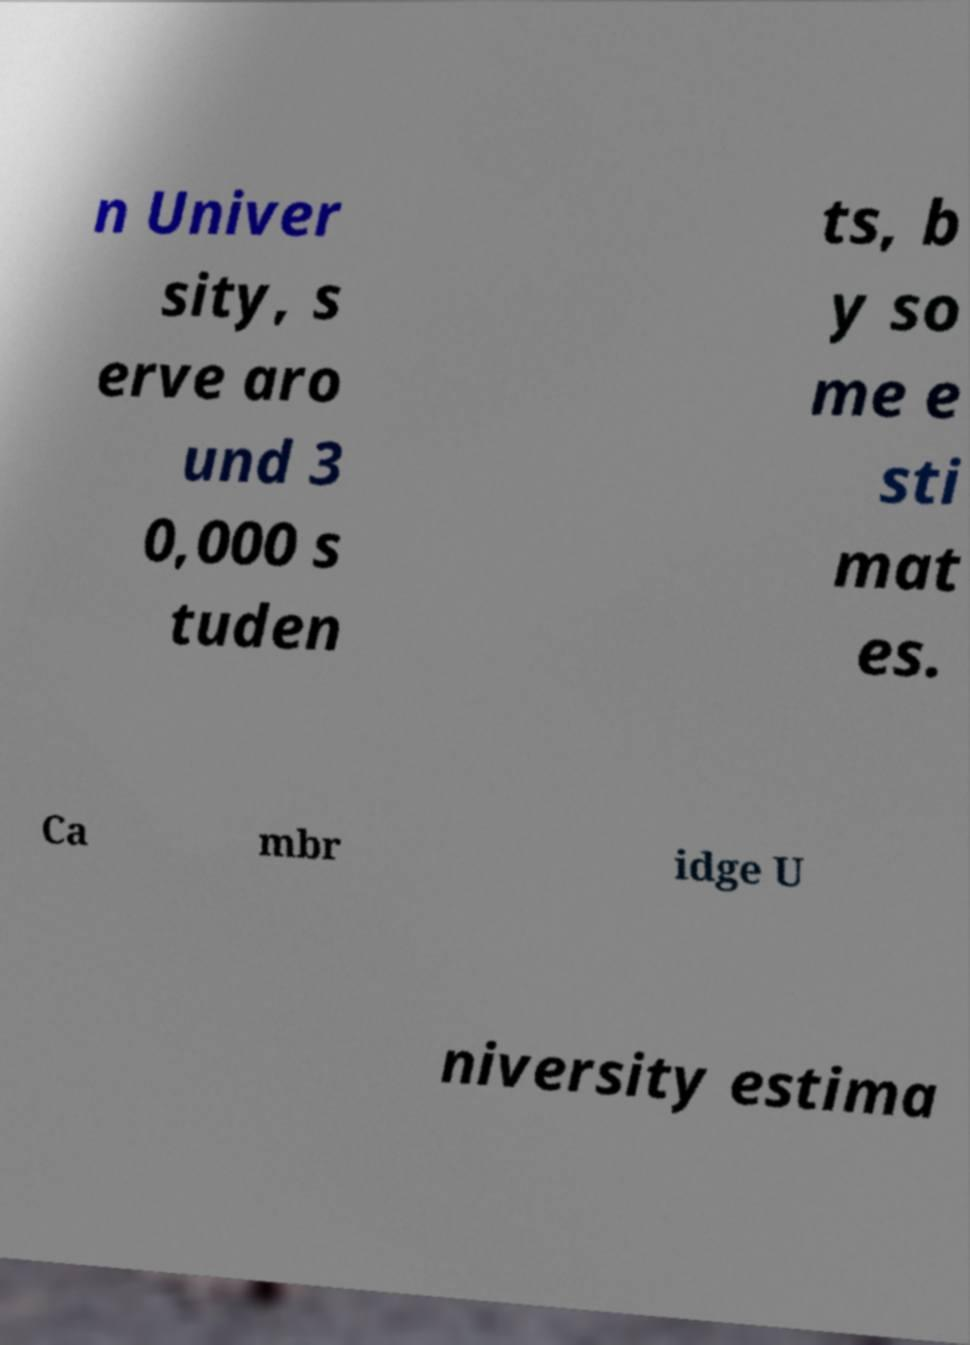For documentation purposes, I need the text within this image transcribed. Could you provide that? n Univer sity, s erve aro und 3 0,000 s tuden ts, b y so me e sti mat es. Ca mbr idge U niversity estima 